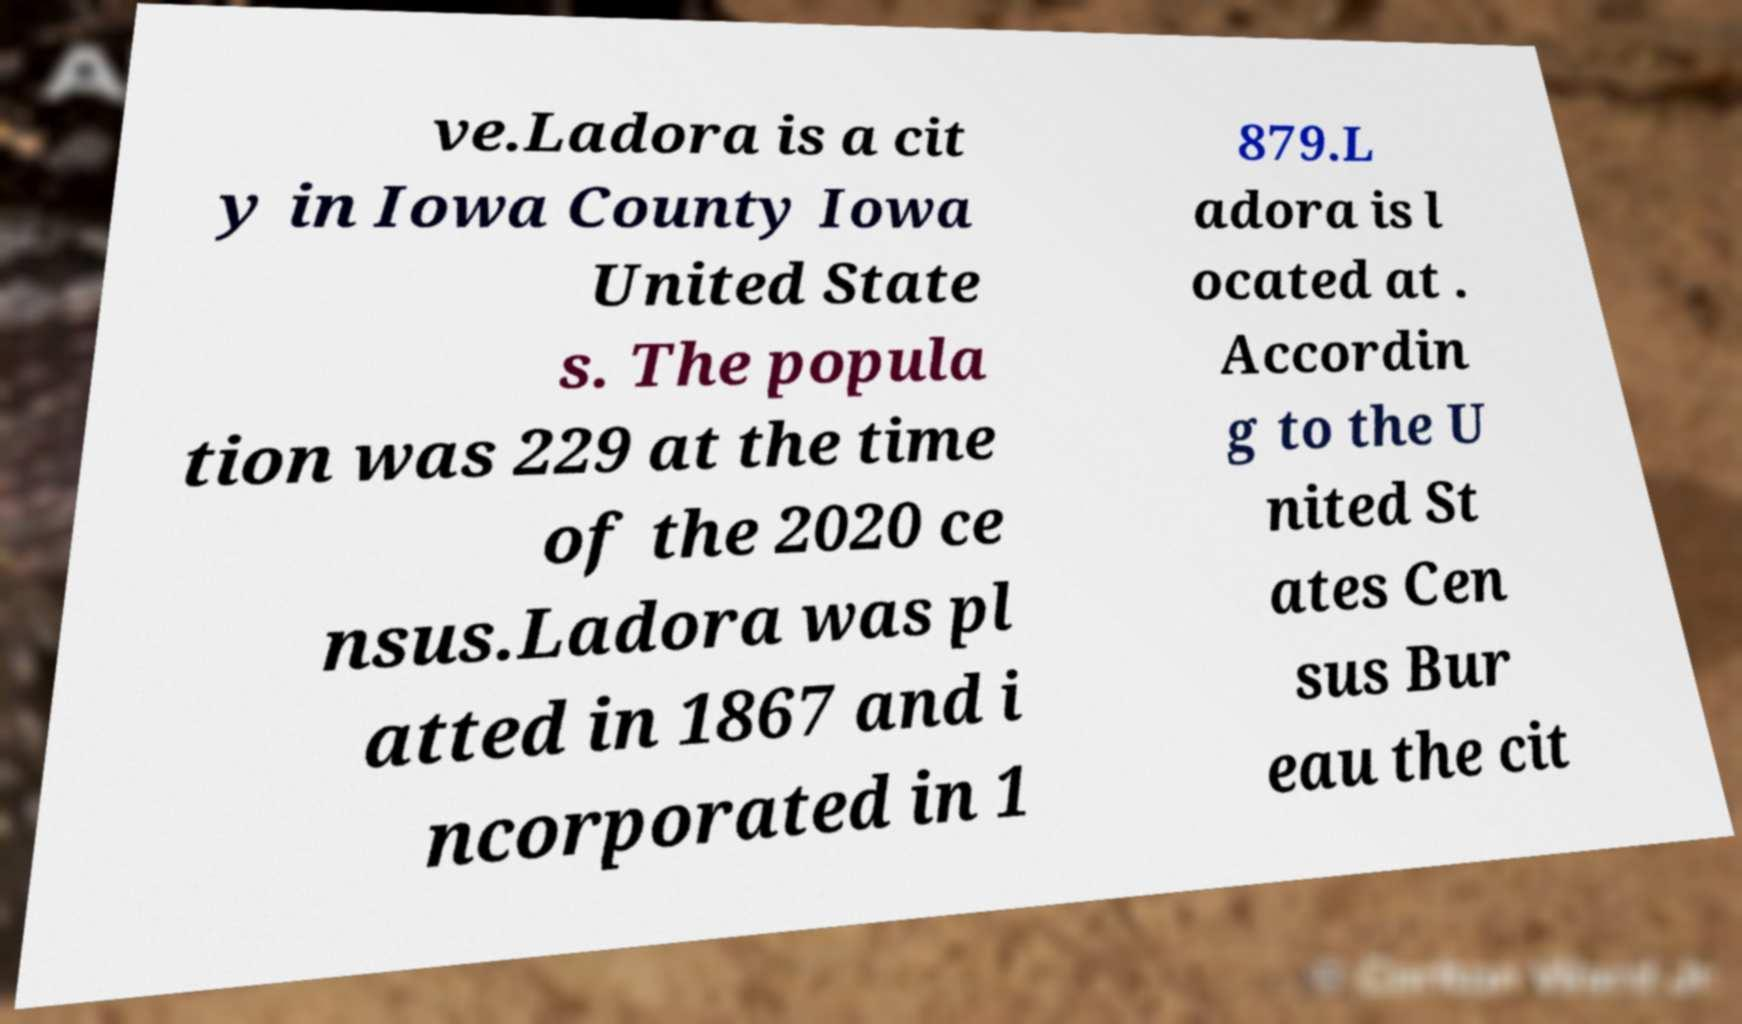For documentation purposes, I need the text within this image transcribed. Could you provide that? ve.Ladora is a cit y in Iowa County Iowa United State s. The popula tion was 229 at the time of the 2020 ce nsus.Ladora was pl atted in 1867 and i ncorporated in 1 879.L adora is l ocated at . Accordin g to the U nited St ates Cen sus Bur eau the cit 